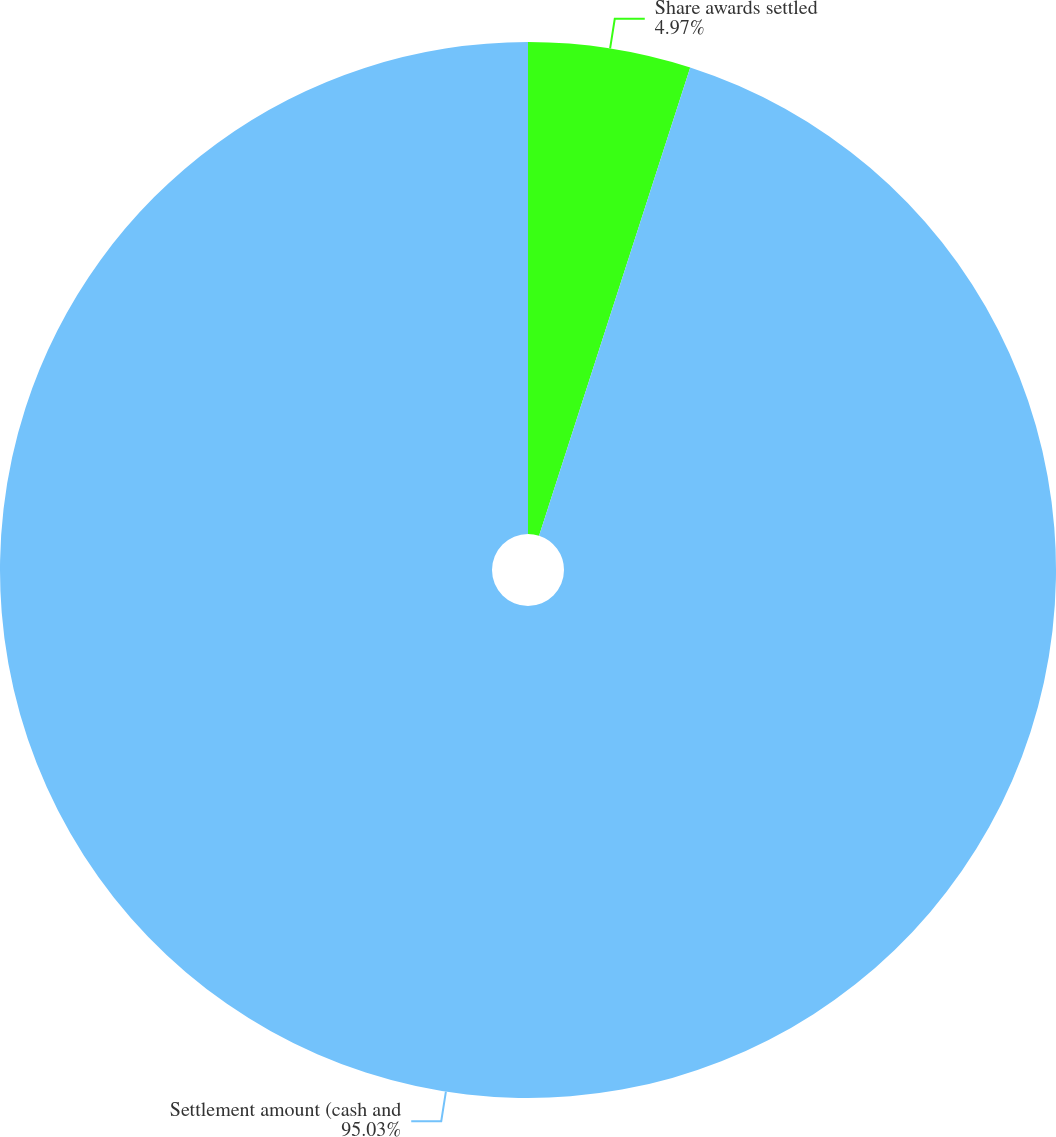Convert chart. <chart><loc_0><loc_0><loc_500><loc_500><pie_chart><fcel>Share awards settled<fcel>Settlement amount (cash and<nl><fcel>4.97%<fcel>95.03%<nl></chart> 